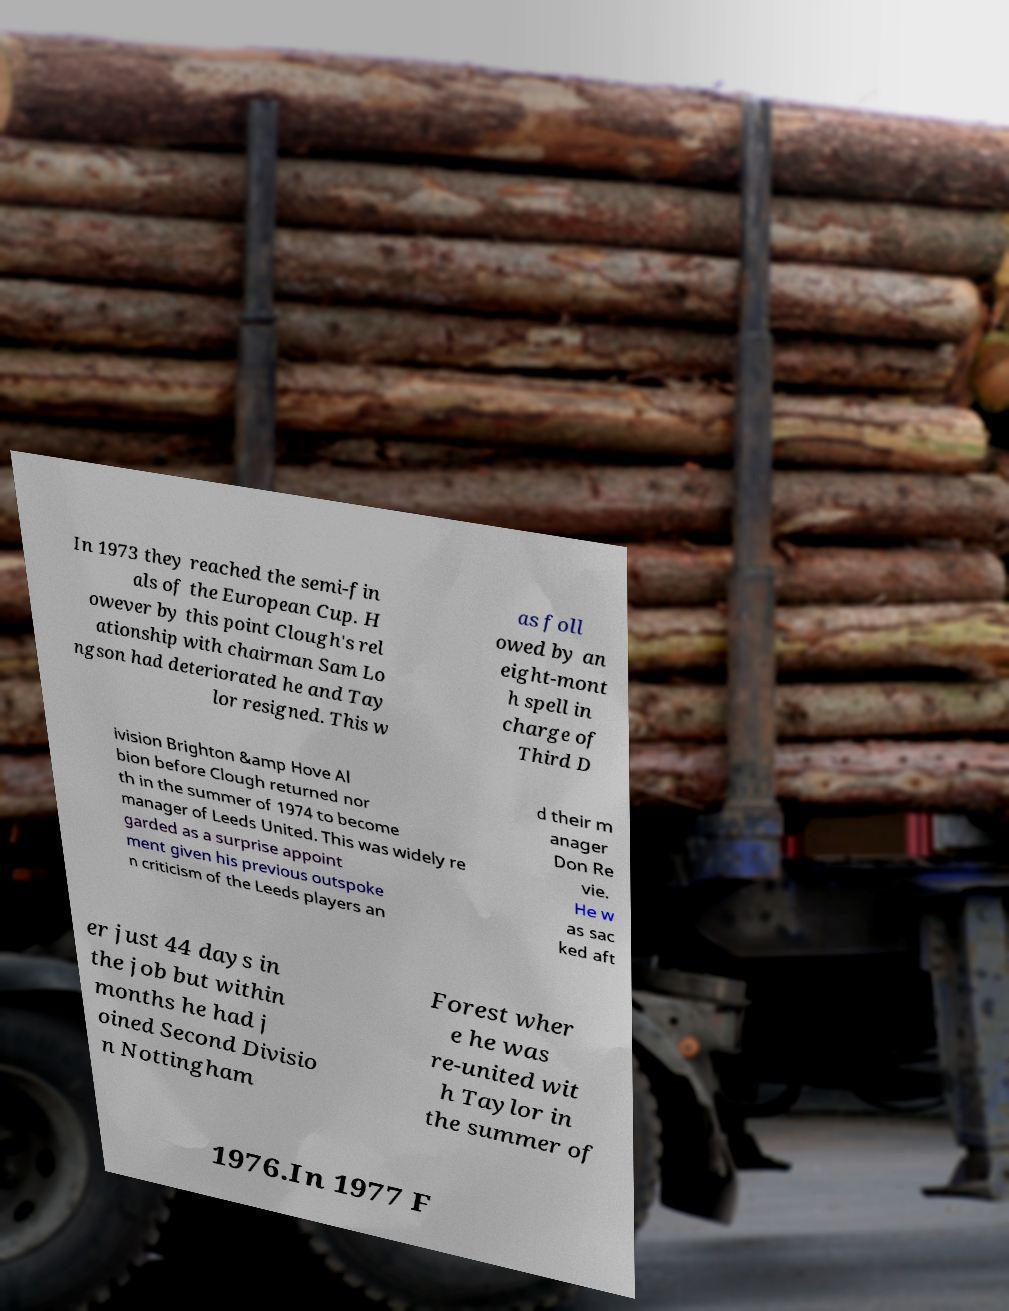For documentation purposes, I need the text within this image transcribed. Could you provide that? In 1973 they reached the semi-fin als of the European Cup. H owever by this point Clough's rel ationship with chairman Sam Lo ngson had deteriorated he and Tay lor resigned. This w as foll owed by an eight-mont h spell in charge of Third D ivision Brighton &amp Hove Al bion before Clough returned nor th in the summer of 1974 to become manager of Leeds United. This was widely re garded as a surprise appoint ment given his previous outspoke n criticism of the Leeds players an d their m anager Don Re vie. He w as sac ked aft er just 44 days in the job but within months he had j oined Second Divisio n Nottingham Forest wher e he was re-united wit h Taylor in the summer of 1976.In 1977 F 